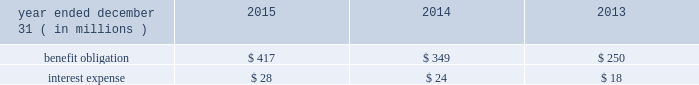Nbcuniversal media , llc our consolidated balance sheet also includes the assets and liabilities of certain legacy pension plans , as well as the assets and liabilities for pension plans of certain foreign subsidiaries .
As of december 31 , 2015 and 2014 , the benefit obligations associated with these plans exceeded the fair value of the plan assets by $ 67 million and $ 51 million , respectively .
Other employee benefits deferred compensation plans we maintain unfunded , nonqualified deferred compensation plans for certain members of management ( each , a 201cparticipant 201d ) .
The amount of compensation deferred by each participant is based on participant elections .
Participants in the plan designate one or more valuation funds , independently established funds or indices that are used to determine the amount of investment gain or loss in the participant 2019s account .
Additionally , certain of our employees participate in comcast 2019s unfunded , nonqualified deferred compensa- tion plan .
The amount of compensation deferred by each participant is based on participant elections .
Participant accounts are credited with income primarily based on a fixed annual rate .
In the case of both deferred compensation plans , participants are eligible to receive distributions from their account based on elected deferral periods that are consistent with the plans and applicable tax law .
The table below presents the benefit obligation and interest expense for our deferred compensation plans. .
Retirement investment plans we sponsor several 401 ( k ) defined contribution retirement plans that allow eligible employees to contribute a portion of their compensation through payroll deductions in accordance with specified plan guidelines .
We make contributions to the plans that include matching a percentage of the employees 2019 contributions up to certain limits .
In 2015 , 2014 and 2013 , expenses related to these plans totaled $ 174 million , $ 165 million and $ 152 million , respectively .
Multiemployer benefit plans we participate in various multiemployer benefit plans , including pension and postretirement benefit plans , that cover some of our employees and temporary employees who are represented by labor unions .
We also partic- ipate in other multiemployer benefit plans that provide health and welfare and retirement savings benefits to active and retired participants .
We make periodic contributions to these plans in accordance with the terms of applicable collective bargaining agreements and laws but do not sponsor or administer these plans .
We do not participate in any multiemployer benefit plans for which we consider our contributions to be individually significant , and the largest plans in which we participate are funded at a level of 80% ( 80 % ) or greater .
In 2015 , 2014 and 2013 , the total contributions we made to multiemployer pension plans were $ 77 million , $ 58 million and $ 59 million , respectively .
In 2015 , 2014 and 2013 , the total contributions we made to multi- employer postretirement and other benefit plans were $ 119 million , $ 125 million and $ 98 million , respectively .
If we cease to be obligated to make contributions or were to otherwise withdraw from participation in any of these plans , applicable law would require us to fund our allocable share of the unfunded vested benefits , which is known as a withdrawal liability .
In addition , actions taken by other participating employers may lead to adverse changes in the financial condition of one of these plans , which could result in an increase in our withdrawal liability .
Comcast 2015 annual report on form 10-k 166 .
What was the percent of the interest expense of the benefit obligation in 2015? 
Computations: (28 / 417)
Answer: 0.06715. 